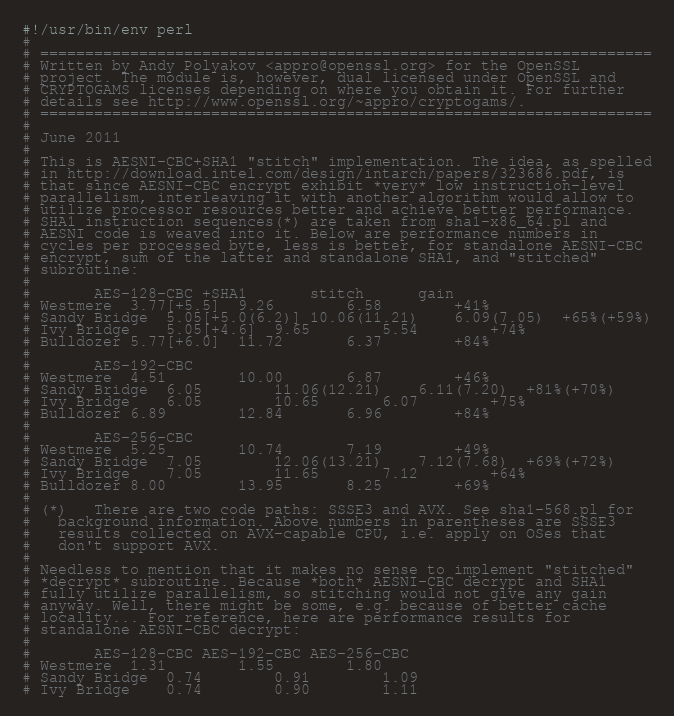<code> <loc_0><loc_0><loc_500><loc_500><_Perl_>#!/usr/bin/env perl
#
# ====================================================================
# Written by Andy Polyakov <appro@openssl.org> for the OpenSSL
# project. The module is, however, dual licensed under OpenSSL and
# CRYPTOGAMS licenses depending on where you obtain it. For further
# details see http://www.openssl.org/~appro/cryptogams/.
# ====================================================================
#
# June 2011
#
# This is AESNI-CBC+SHA1 "stitch" implementation. The idea, as spelled
# in http://download.intel.com/design/intarch/papers/323686.pdf, is
# that since AESNI-CBC encrypt exhibit *very* low instruction-level
# parallelism, interleaving it with another algorithm would allow to
# utilize processor resources better and achieve better performance.
# SHA1 instruction sequences(*) are taken from sha1-x86_64.pl and
# AESNI code is weaved into it. Below are performance numbers in
# cycles per processed byte, less is better, for standalone AESNI-CBC
# encrypt, sum of the latter and standalone SHA1, and "stitched"
# subroutine:
#
#		AES-128-CBC	+SHA1		stitch      gain
# Westmere	3.77[+5.5]	9.26		6.58	    +41%
# Sandy Bridge	5.05[+5.0(6.2)]	10.06(11.21)	6.09(7.05)  +65%(+59%)
# Ivy Bridge	5.05[+4.6]	9.65		5.54        +74%
# Bulldozer	5.77[+6.0]	11.72		6.37        +84%
#
#		AES-192-CBC
# Westmere	4.51		10.00		6.87	    +46%
# Sandy Bridge	6.05		11.06(12.21)	6.11(7.20)  +81%(+70%)
# Ivy Bridge	6.05		10.65		6.07        +75%
# Bulldozer	6.89		12.84		6.96        +84%
#
#		AES-256-CBC
# Westmere	5.25		10.74		7.19	    +49%
# Sandy Bridge	7.05		12.06(13.21)	7.12(7.68)  +69%(+72%)
# Ivy Bridge	7.05		11.65		7.12        +64%
# Bulldozer	8.00		13.95		8.25        +69%
#
# (*)	There are two code paths: SSSE3 and AVX. See sha1-568.pl for
#	background information. Above numbers in parentheses are SSSE3
#	results collected on AVX-capable CPU, i.e. apply on OSes that
#	don't support AVX.
#
# Needless to mention that it makes no sense to implement "stitched"
# *decrypt* subroutine. Because *both* AESNI-CBC decrypt and SHA1
# fully utilize parallelism, so stitching would not give any gain
# anyway. Well, there might be some, e.g. because of better cache
# locality... For reference, here are performance results for
# standalone AESNI-CBC decrypt:
#
#		AES-128-CBC	AES-192-CBC	AES-256-CBC
# Westmere	1.31		1.55		1.80
# Sandy Bridge	0.74		0.91		1.09
# Ivy Bridge	0.74		0.90		1.11</code> 